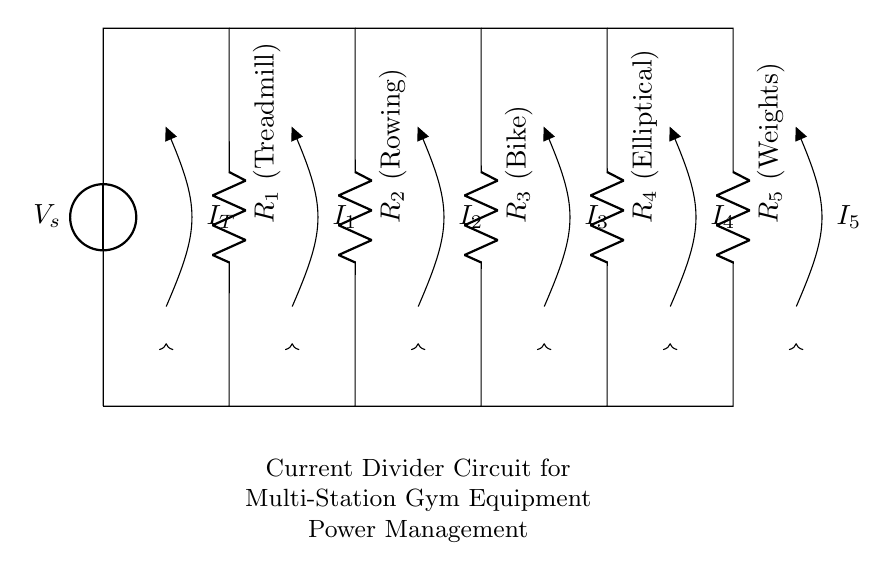What is the total voltage supplied to the circuit? The total voltage supplied to the circuit from the voltage source is indicated by \( V_s \) at the top of the diagram. The exact value is not specified but is typically a fixed voltage for this setup.
Answer: V_s How many resistors are in parallel in this circuit? The circuit diagram shows five resistors (R1, R2, R3, R4, R5) connected in parallel, as indicated by their arrangement between the same voltage points at the top and bottom of the circuit diagram.
Answer: 5 What is the current flowing through the treadmill? The current flowing through the treadmill is represented by \( I_1 \) in the diagram, which is one of the branches in this parallel circuit. The value for \( I_1 \) is not specified in the diagram but is calculated using the current divider rule based on \( I_T \) and the resistances.
Answer: I_1 Which piece of equipment has the highest resistance? Looking at the resistors represented in the circuit, the piece of equipment with the highest resistance corresponds to the resistor with the largest written label within the context, which is not given a numeric value. Without values, it is unclear, but it can still be concluded that resistance impacts current distribution.
Answer: R5 (Weights could be inferred to have a higher resistance if it aligned with standard design practices.) What is the total current entering the circuit? The total current entering the circuit is represented by \( I_T \), which is the sum of all individual currents (\( I_1, I_2, I_3, I_4, I_5 \)) flowing into the parallel resistors. The total current can be calculated by using the formula based on the voltage and the equivalent resistance of the parallel resistors.
Answer: I_T What type of circuit is represented here? The circuit shown is a current divider circuit because it divides the total current \( I_T \) among multiple parallel paths, allowing each piece of gym equipment to effectively receive its required share of current.
Answer: Current Divider How does increasing resistance in one branch affect the currents in others? Increasing resistance in one branch will lead to a decrease in the current flowing through that branch, as per Ohm's Law. However, since the resistors are in parallel, the total current \( I_T \) remains constant, which means that the current through the other branches will increase as more total current is available to distribute amongst the lower resistance paths.
Answer: More current in other branches 